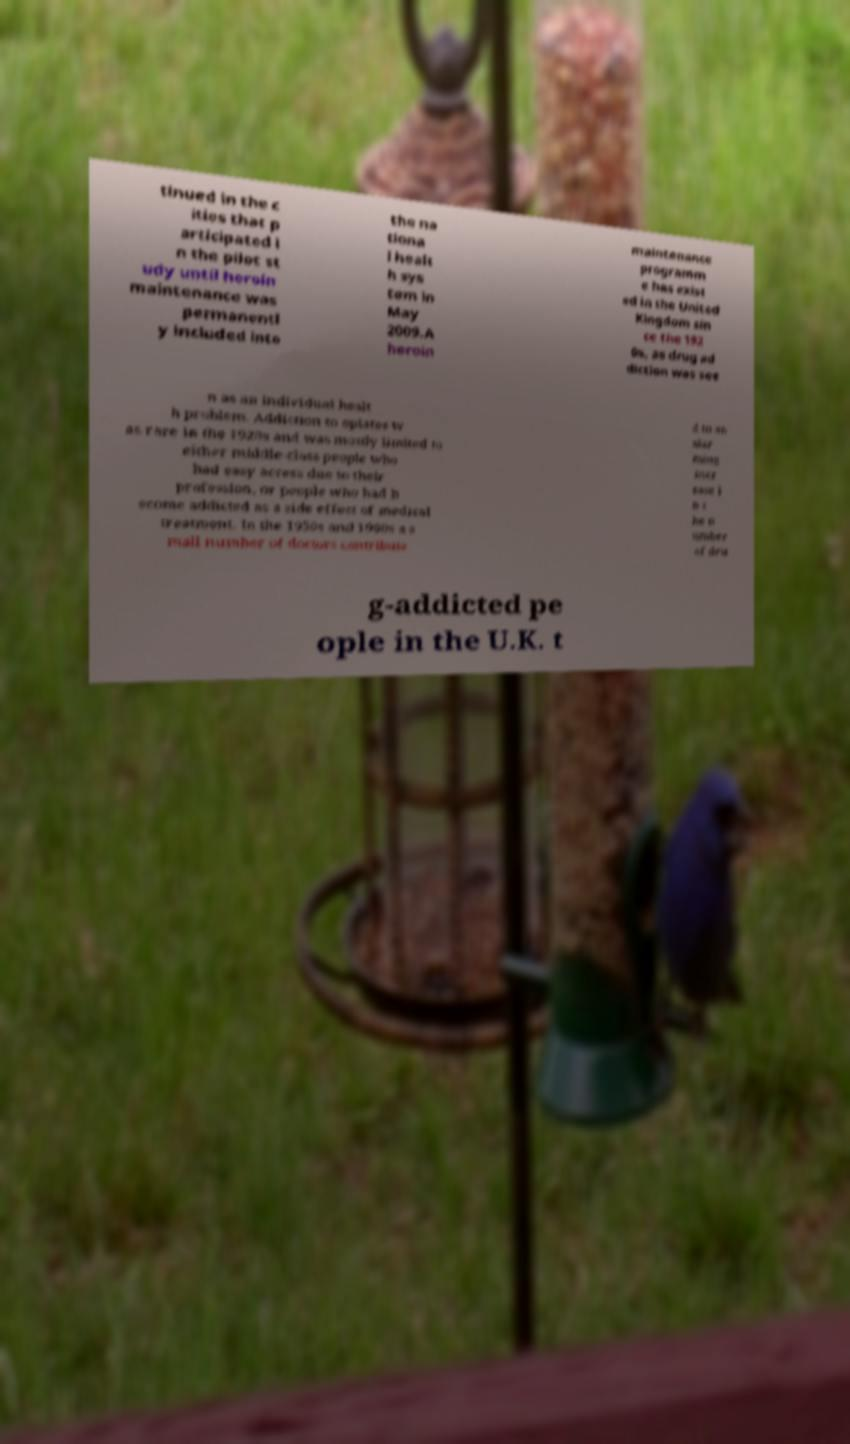Please read and relay the text visible in this image. What does it say? tinued in the c ities that p articipated i n the pilot st udy until heroin maintenance was permanentl y included into the na tiona l healt h sys tem in May 2009.A heroin maintenance programm e has exist ed in the United Kingdom sin ce the 192 0s, as drug ad diction was see n as an individual healt h problem. Addiction to opiates w as rare in the 1920s and was mostly limited to either middle-class people who had easy access due to their profession, or people who had b ecome addicted as a side effect of medical treatment. In the 1950s and 1960s a s mall number of doctors contribute d to an alar ming incr ease i n t he n umber of dru g-addicted pe ople in the U.K. t 